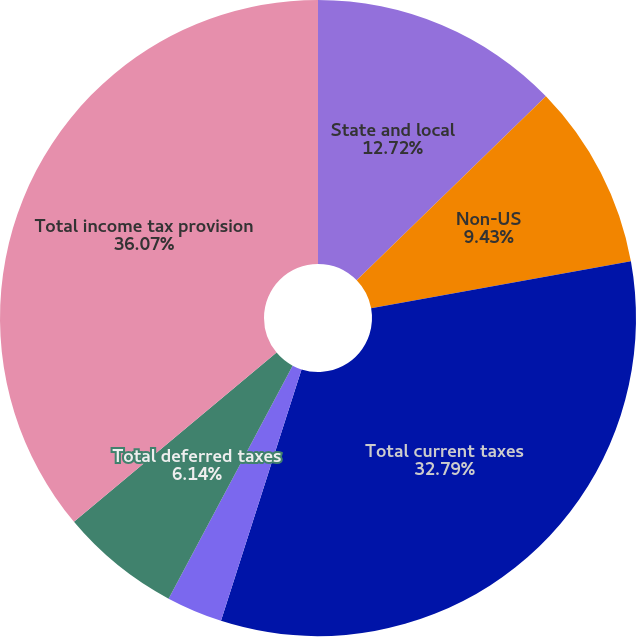Convert chart. <chart><loc_0><loc_0><loc_500><loc_500><pie_chart><fcel>State and local<fcel>Non-US<fcel>Total current taxes<fcel>US federal<fcel>Total deferred taxes<fcel>Total income tax provision<nl><fcel>12.72%<fcel>9.43%<fcel>32.79%<fcel>2.85%<fcel>6.14%<fcel>36.08%<nl></chart> 